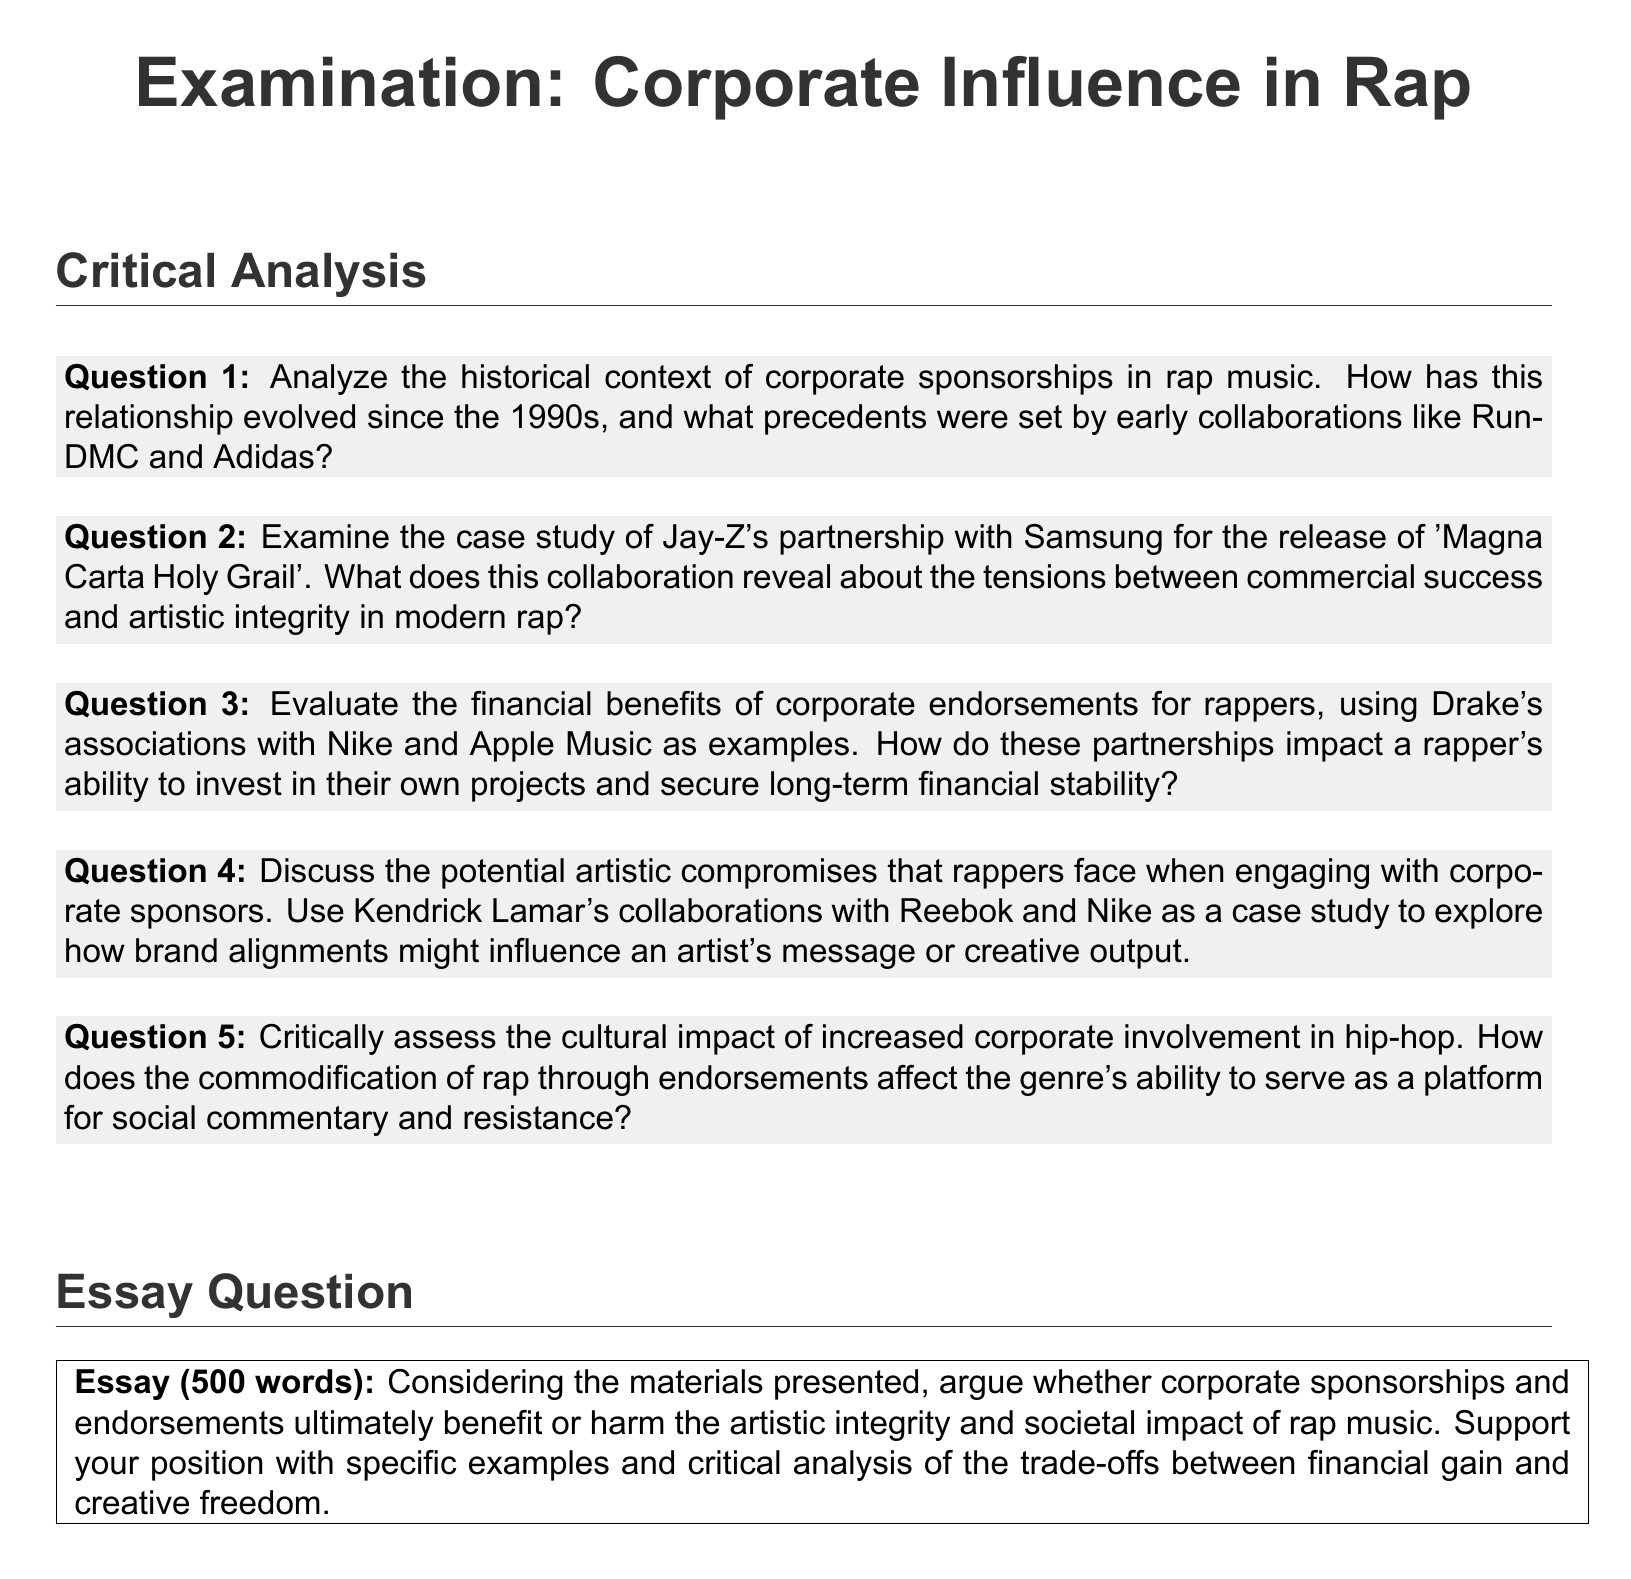What is the title of the exam? The title of the exam is presented at the top of the document in a prominent font.
Answer: Examination: Corporate Influence in Rap How many main sections are in the examination? The document contains two main sections, one for critical analysis and one for the essay question.
Answer: 2 Who is mentioned in connection with a partnership for the release of 'Magna Carta Holy Grail'? The name mentioned regarding the partnership for 'Magna Carta Holy Grail' is part of a case study within the document.
Answer: Jay-Z What is the word count requirement for the essay question? The essay question specifies a word count that must be adhered to for submissions.
Answer: 500 words Which rapper's endorsements with Nike and Apple Music are cited as examples of financial benefits? The document refers to endorsements that give insight into financial security and project investment in modern rap.
Answer: Drake What brand did Kendrick Lamar collaborate with for his endorsements? The document highlights specific collaborations that may affect a rapper’s creative output and message.
Answer: Reebok What does the essay question ask the respondent to argue about? The essay question solicits a specific position on the impact of corporate sponsorships and endorsements on artistic integrity and societal influence.
Answer: Benefit or harm What is the color of the background used in the document? The document design mentions a specified backdrop color that contributes to its aesthetic.
Answer: White 